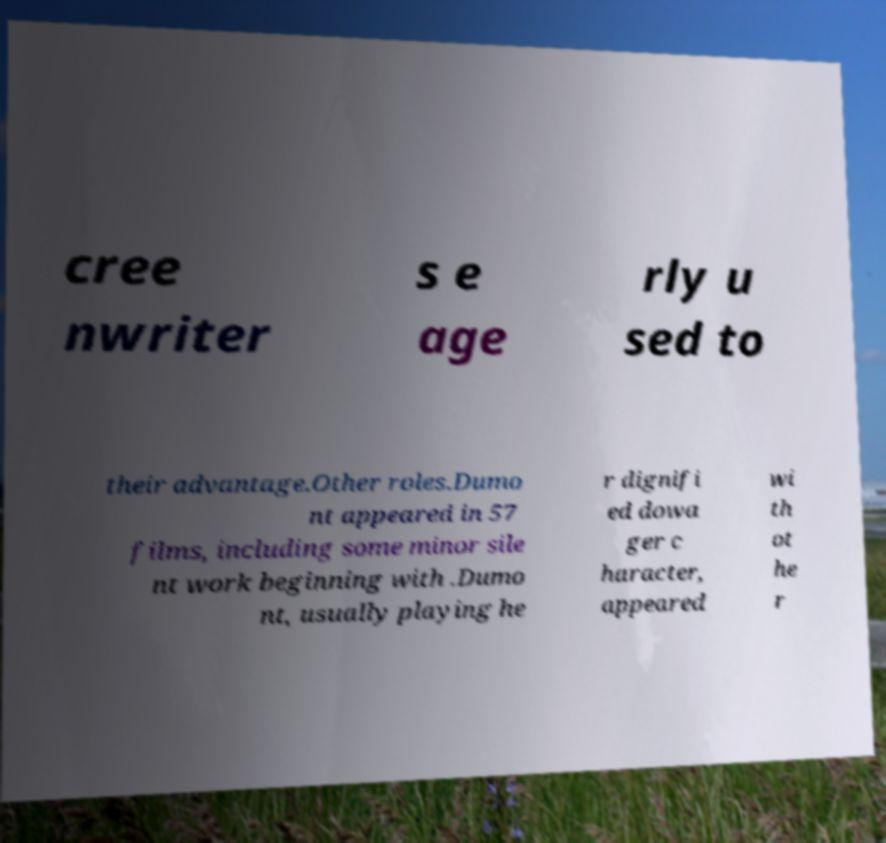For documentation purposes, I need the text within this image transcribed. Could you provide that? cree nwriter s e age rly u sed to their advantage.Other roles.Dumo nt appeared in 57 films, including some minor sile nt work beginning with .Dumo nt, usually playing he r dignifi ed dowa ger c haracter, appeared wi th ot he r 